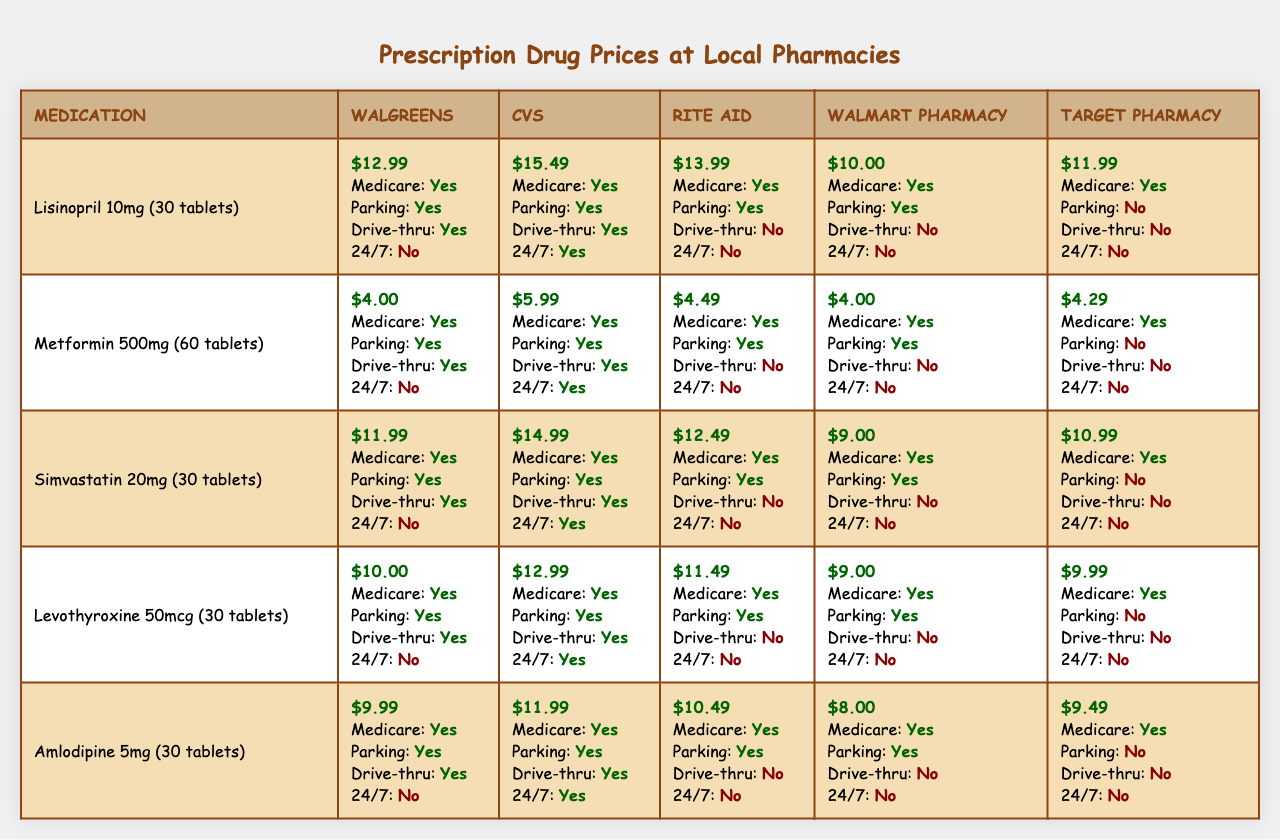What is the price of Lisinopril at Walmart Pharmacy? From the table, under the medication Lisinopril 10mg (30 tablets), the price at Walmart Pharmacy is listed as $10.00.
Answer: $10.00 Which pharmacy offers the lowest price for Amlodipine? Looking at the Amlodipine 5mg (30 tablets) row, the prices are: Walgreens $9.99, CVS $11.99, Rite Aid $10.49, Walmart Pharmacy $8.00, and Target Pharmacy $9.49. The lowest price is at Walmart Pharmacy, which is $8.00.
Answer: $8.00 Does CVS accept Medicare? The table indicates that CVS has "Yes" listed under accepts Medicare, confirming that it does accept Medicare.
Answer: Yes Which pharmacy has a drive-thru service for Simvastatin? For Simvastatin 20mg (30 tablets), the table shows prices as well as features. Looking at the drive-thru column, Walgreens and CVS both have "Yes" listed for drive-thru service.
Answer: Walgreens and CVS What is the price difference between the most expensive and cheapest price for Metformin? The prices for Metformin 500mg (60 tablets) are: Walgreens $4.00, CVS $5.99, Rite Aid $4.49, Walmart Pharmacy $4.00, Target Pharmacy $4.29. The highest price is $5.99 (CVS) and the lowest is $4.00 (Walgreens), leading to a difference of $5.99 - $4.00 = $1.99.
Answer: $1.99 Which pharmacy has the highest price for Levothyroxine? Checking the prices for Levothyroxine 50mcg (30 tablets), we have: Walgreens $10.00, CVS $12.99, Rite Aid $11.49, Walmart Pharmacy $9.00, and Target Pharmacy $9.99. The highest price is $12.99 at CVS.
Answer: $12.99 How many pharmacies are open 24 hours? The open 24 hours column shows the following: Walgreens No, CVS Yes, Rite Aid No, Walmart Pharmacy No, Target Pharmacy No. Only CVS is open 24 hours, so the count is 1.
Answer: 1 What is the average price of Simvastatin across all pharmacies? For Simvastatin 20mg (30 tablets), the prices are Walgreens $11.99, CVS $14.99, Rite Aid $12.49, Walmart Pharmacy $9.00, Target Pharmacy $10.99. The total price is $11.99 + $14.99 + $12.49 + $9.00 + $10.99 = $59.46. Dividing by 5 gives the average: $59.46 / 5 = $11.892.
Answer: $11.89 Which pharmacy does not have parking available? The parking available column shows: Walgreens Yes, CVS Yes, Rite Aid Yes, Walmart Pharmacy Yes, Target Pharmacy No. Target Pharmacy is the only one without parking available.
Answer: Target Pharmacy What is the difference in price between Levothyroxine at Walgreens and CVS? Looking at the prices for Levothyroxine 50mcg (30 tablets), Walgreens is $10.00 and CVS is $12.99. The price difference is $12.99 - $10.00 = $2.99.
Answer: $2.99 Which medications can be obtained at the pharmacy with a drive-thru? Checking the drive-thru column, the medications with drive-thru availability are: Lisinopril (Walgreens, CVS), Metformin (Walgreens, CVS), Simvastatin (none), Levothyroxine (none), and Amlodipine (none). Thus, Lisinopril and Metformin can be obtained with drive-thru service at Walgreens and CVS.
Answer: Lisinopril and Metformin at Walgreens and CVS 